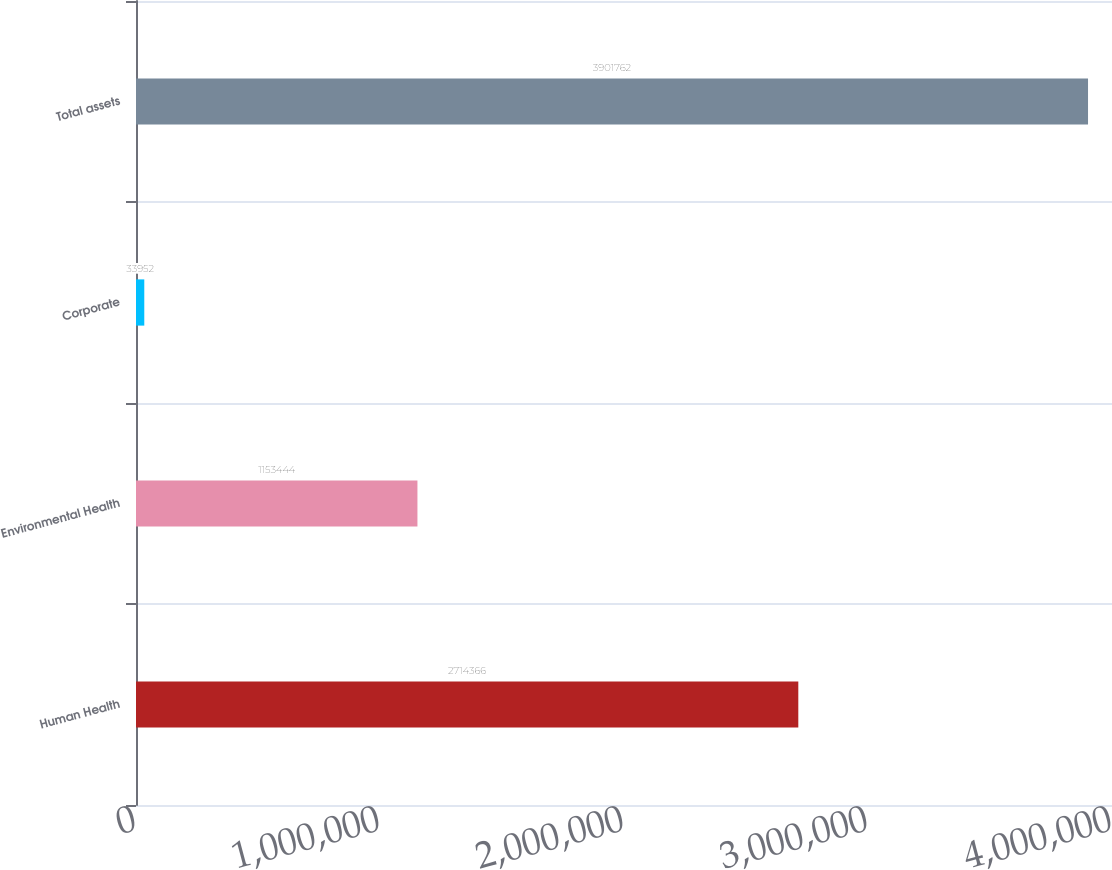Convert chart. <chart><loc_0><loc_0><loc_500><loc_500><bar_chart><fcel>Human Health<fcel>Environmental Health<fcel>Corporate<fcel>Total assets<nl><fcel>2.71437e+06<fcel>1.15344e+06<fcel>33952<fcel>3.90176e+06<nl></chart> 